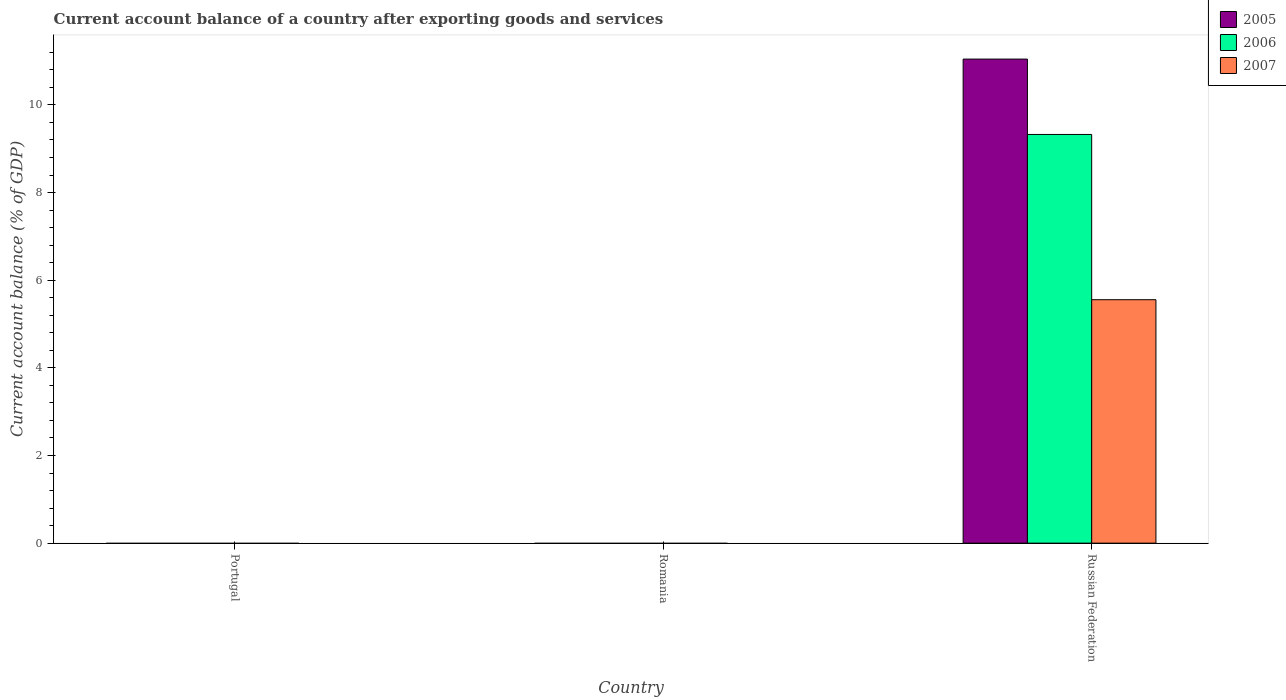Are the number of bars on each tick of the X-axis equal?
Your response must be concise. No. How many bars are there on the 3rd tick from the right?
Your answer should be compact. 0. In how many cases, is the number of bars for a given country not equal to the number of legend labels?
Provide a short and direct response. 2. What is the account balance in 2007 in Russian Federation?
Provide a succinct answer. 5.55. Across all countries, what is the maximum account balance in 2006?
Make the answer very short. 9.33. In which country was the account balance in 2005 maximum?
Keep it short and to the point. Russian Federation. What is the total account balance in 2007 in the graph?
Your response must be concise. 5.55. What is the difference between the account balance in 2005 in Russian Federation and the account balance in 2006 in Portugal?
Keep it short and to the point. 11.05. What is the average account balance in 2006 per country?
Your answer should be very brief. 3.11. What is the difference between the account balance of/in 2007 and account balance of/in 2006 in Russian Federation?
Provide a short and direct response. -3.77. What is the difference between the highest and the lowest account balance in 2006?
Ensure brevity in your answer.  9.33. In how many countries, is the account balance in 2006 greater than the average account balance in 2006 taken over all countries?
Give a very brief answer. 1. Are the values on the major ticks of Y-axis written in scientific E-notation?
Your answer should be very brief. No. Does the graph contain any zero values?
Give a very brief answer. Yes. Does the graph contain grids?
Your response must be concise. No. How many legend labels are there?
Your answer should be compact. 3. What is the title of the graph?
Offer a very short reply. Current account balance of a country after exporting goods and services. Does "1988" appear as one of the legend labels in the graph?
Provide a short and direct response. No. What is the label or title of the X-axis?
Your answer should be very brief. Country. What is the label or title of the Y-axis?
Offer a very short reply. Current account balance (% of GDP). What is the Current account balance (% of GDP) of 2005 in Russian Federation?
Your answer should be very brief. 11.05. What is the Current account balance (% of GDP) in 2006 in Russian Federation?
Provide a short and direct response. 9.33. What is the Current account balance (% of GDP) in 2007 in Russian Federation?
Offer a terse response. 5.55. Across all countries, what is the maximum Current account balance (% of GDP) of 2005?
Make the answer very short. 11.05. Across all countries, what is the maximum Current account balance (% of GDP) of 2006?
Provide a short and direct response. 9.33. Across all countries, what is the maximum Current account balance (% of GDP) in 2007?
Offer a terse response. 5.55. Across all countries, what is the minimum Current account balance (% of GDP) in 2006?
Your answer should be very brief. 0. What is the total Current account balance (% of GDP) of 2005 in the graph?
Your response must be concise. 11.05. What is the total Current account balance (% of GDP) of 2006 in the graph?
Your answer should be very brief. 9.33. What is the total Current account balance (% of GDP) in 2007 in the graph?
Offer a terse response. 5.55. What is the average Current account balance (% of GDP) in 2005 per country?
Offer a terse response. 3.68. What is the average Current account balance (% of GDP) of 2006 per country?
Your answer should be very brief. 3.11. What is the average Current account balance (% of GDP) in 2007 per country?
Your response must be concise. 1.85. What is the difference between the Current account balance (% of GDP) of 2005 and Current account balance (% of GDP) of 2006 in Russian Federation?
Give a very brief answer. 1.72. What is the difference between the Current account balance (% of GDP) in 2005 and Current account balance (% of GDP) in 2007 in Russian Federation?
Your answer should be very brief. 5.49. What is the difference between the Current account balance (% of GDP) in 2006 and Current account balance (% of GDP) in 2007 in Russian Federation?
Keep it short and to the point. 3.77. What is the difference between the highest and the lowest Current account balance (% of GDP) in 2005?
Offer a very short reply. 11.05. What is the difference between the highest and the lowest Current account balance (% of GDP) in 2006?
Provide a succinct answer. 9.33. What is the difference between the highest and the lowest Current account balance (% of GDP) of 2007?
Offer a very short reply. 5.55. 